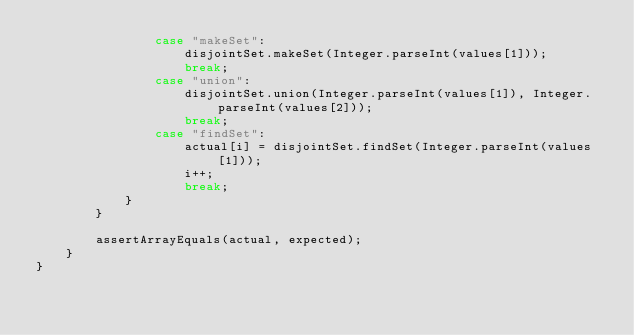<code> <loc_0><loc_0><loc_500><loc_500><_Java_>                case "makeSet":
                    disjointSet.makeSet(Integer.parseInt(values[1]));
                    break;
                case "union":
                    disjointSet.union(Integer.parseInt(values[1]), Integer.parseInt(values[2]));
                    break;
                case "findSet":
                    actual[i] = disjointSet.findSet(Integer.parseInt(values[1]));
                    i++;
                    break;
            }
        }

        assertArrayEquals(actual, expected);
    }
}
</code> 